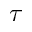<formula> <loc_0><loc_0><loc_500><loc_500>\tau</formula> 